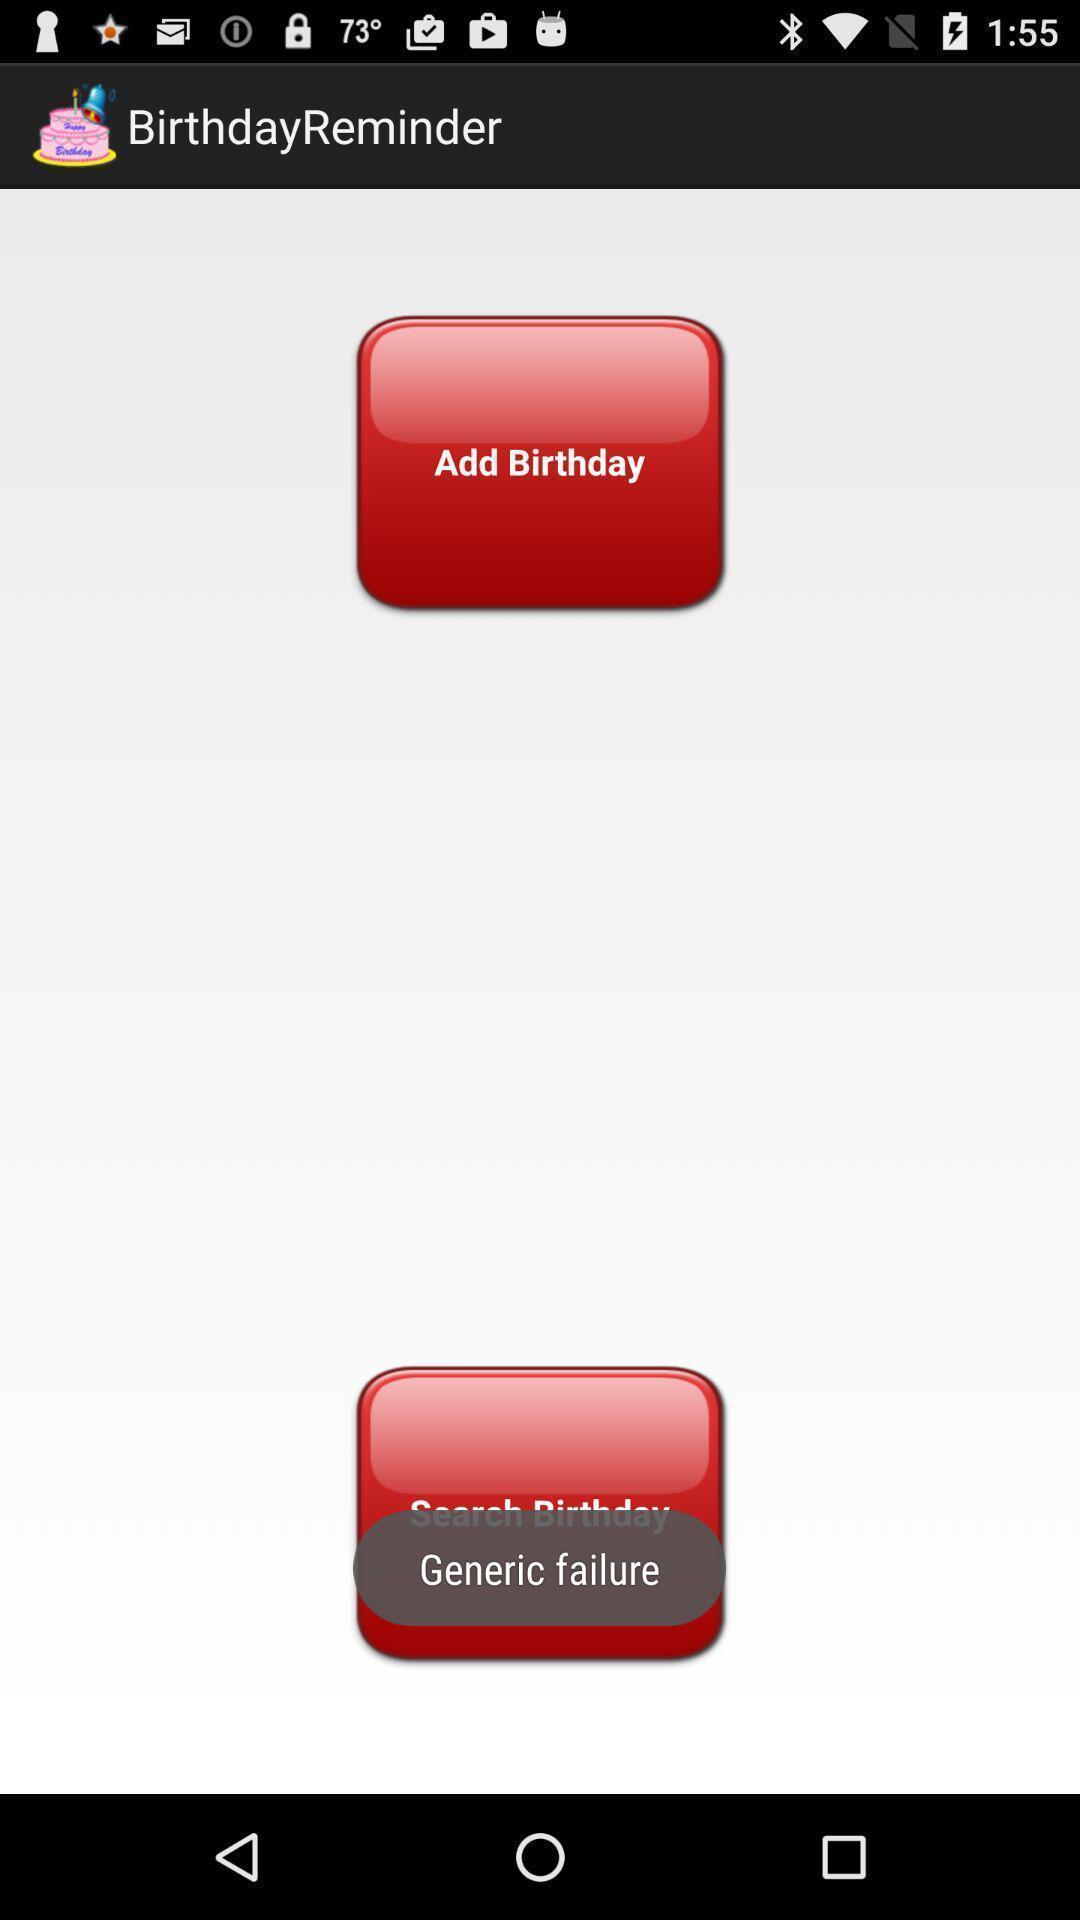Please provide a description for this image. Page displaying the birthday remainder. 